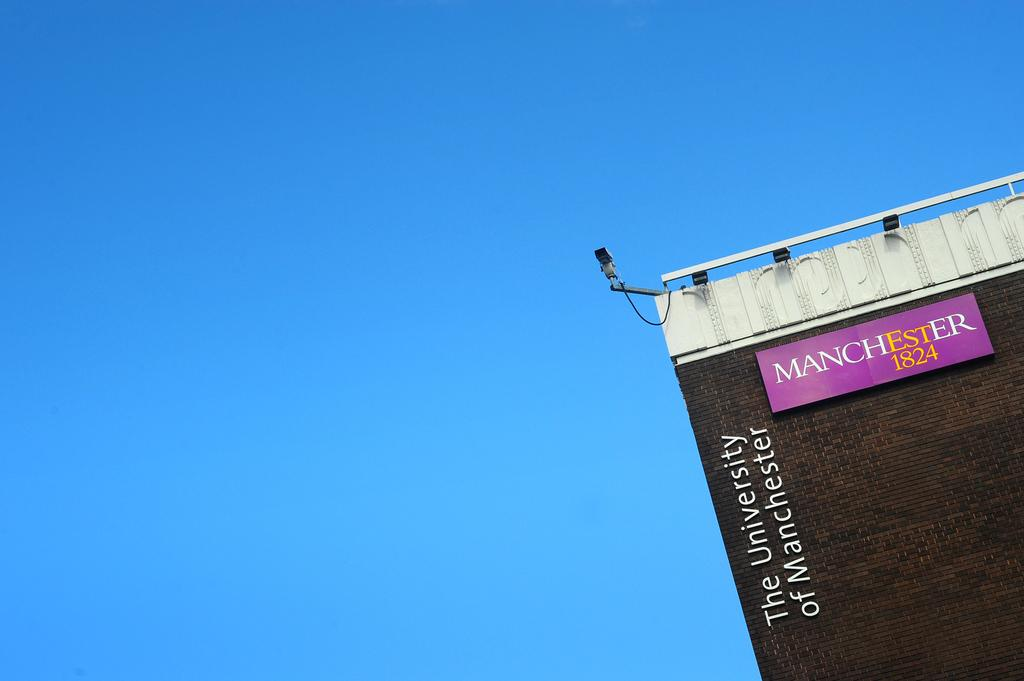Provide a one-sentence caption for the provided image. A building saying the university of manchester on it. 